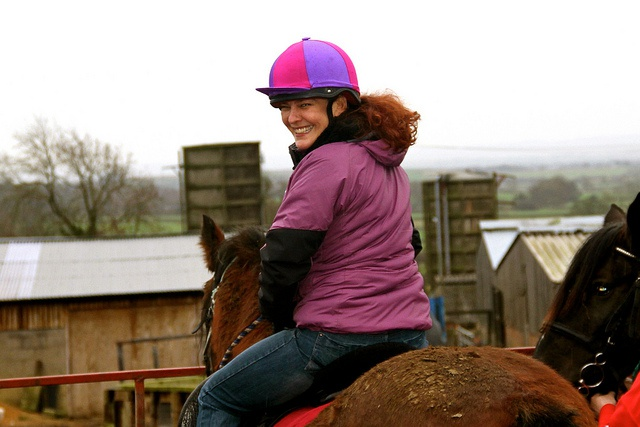Describe the objects in this image and their specific colors. I can see people in white, black, brown, maroon, and purple tones, horse in white, maroon, black, and brown tones, and horse in white, black, maroon, and gray tones in this image. 